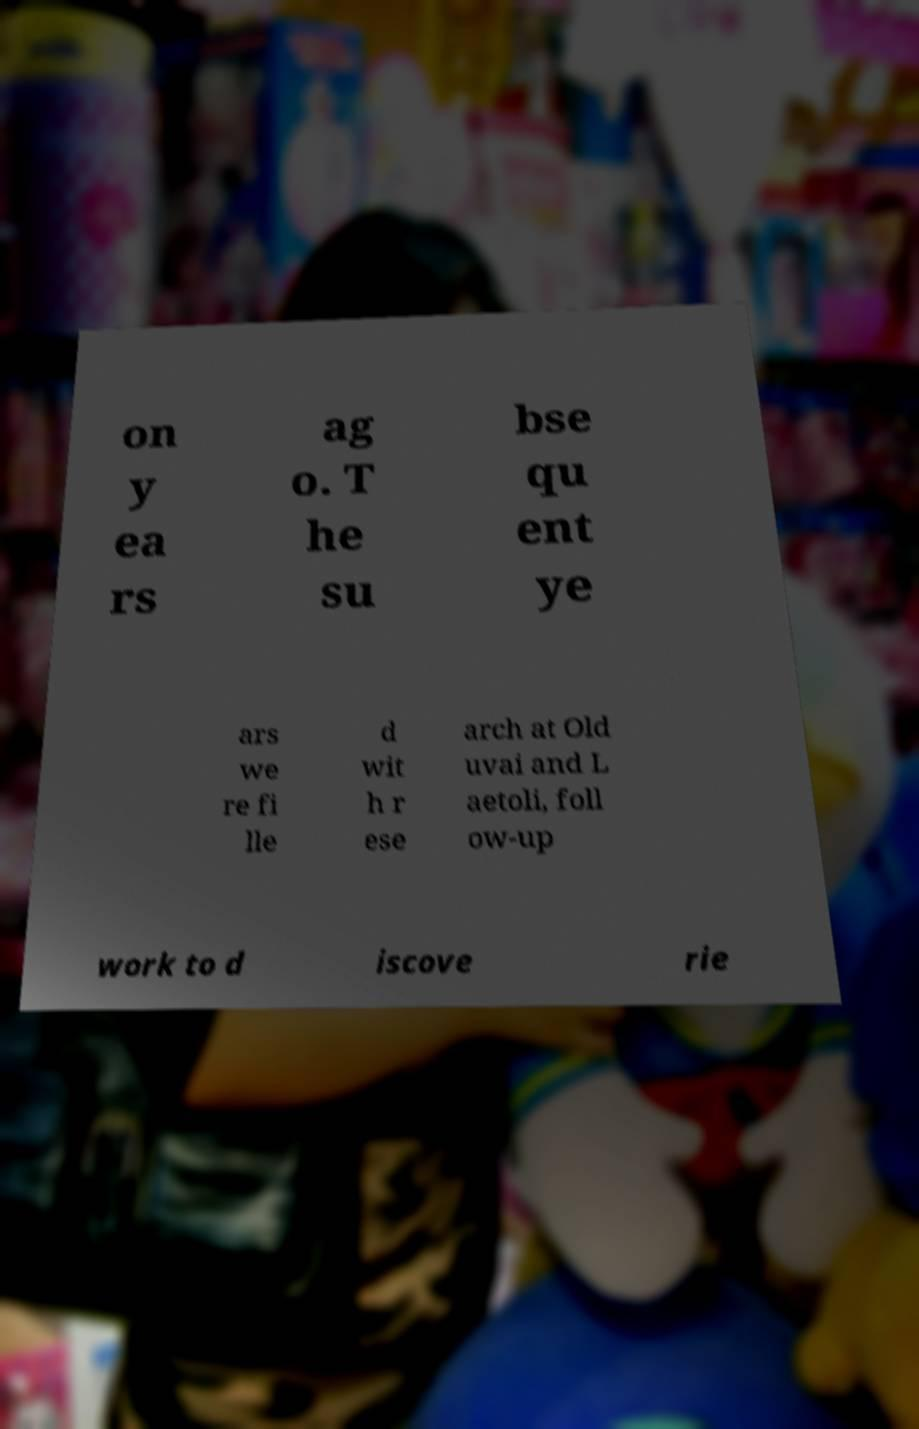Can you accurately transcribe the text from the provided image for me? on y ea rs ag o. T he su bse qu ent ye ars we re fi lle d wit h r ese arch at Old uvai and L aetoli, foll ow-up work to d iscove rie 